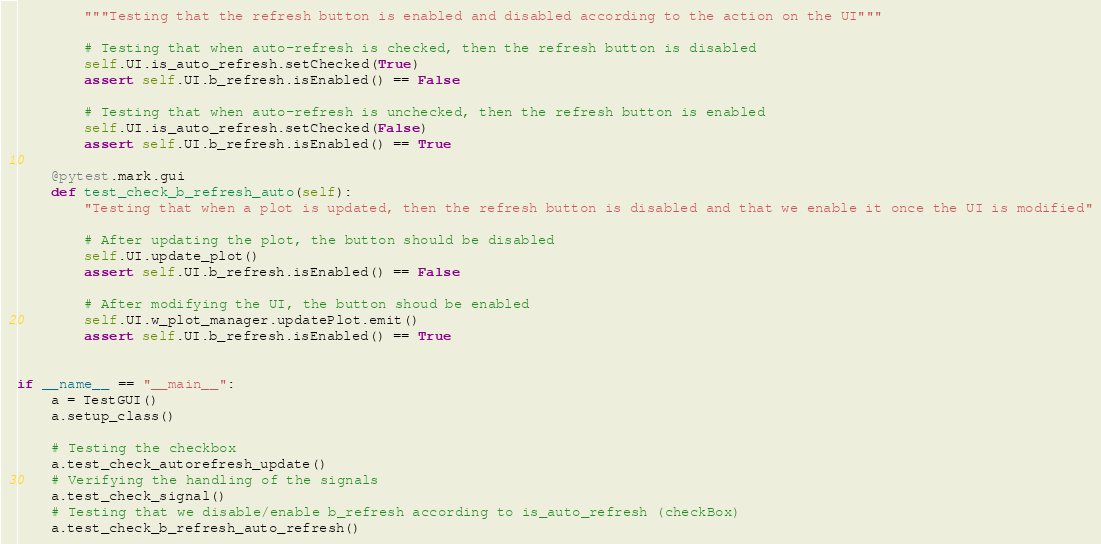<code> <loc_0><loc_0><loc_500><loc_500><_Python_>        """Testing that the refresh button is enabled and disabled according to the action on the UI"""

        # Testing that when auto-refresh is checked, then the refresh button is disabled
        self.UI.is_auto_refresh.setChecked(True)
        assert self.UI.b_refresh.isEnabled() == False

        # Testing that when auto-refresh is unchecked, then the refresh button is enabled
        self.UI.is_auto_refresh.setChecked(False)
        assert self.UI.b_refresh.isEnabled() == True

    @pytest.mark.gui
    def test_check_b_refresh_auto(self):
        "Testing that when a plot is updated, then the refresh button is disabled and that we enable it once the UI is modified"

        # After updating the plot, the button should be disabled
        self.UI.update_plot()
        assert self.UI.b_refresh.isEnabled() == False

        # After modifying the UI, the button shoud be enabled
        self.UI.w_plot_manager.updatePlot.emit()
        assert self.UI.b_refresh.isEnabled() == True


if __name__ == "__main__":
    a = TestGUI()
    a.setup_class()

    # Testing the checkbox
    a.test_check_autorefresh_update()
    # Verifying the handling of the signals
    a.test_check_signal()
    # Testing that we disable/enable b_refresh according to is_auto_refresh (checkBox)
    a.test_check_b_refresh_auto_refresh()</code> 